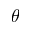<formula> <loc_0><loc_0><loc_500><loc_500>\theta</formula> 